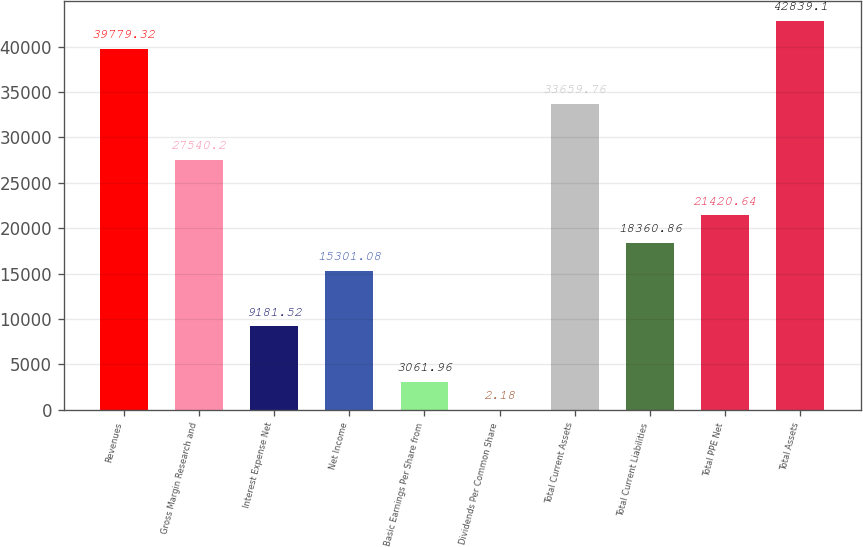Convert chart. <chart><loc_0><loc_0><loc_500><loc_500><bar_chart><fcel>Revenues<fcel>Gross Margin Research and<fcel>Interest Expense Net<fcel>Net Income<fcel>Basic Earnings Per Share from<fcel>Dividends Per Common Share<fcel>Total Current Assets<fcel>Total Current Liabilities<fcel>Total PPE Net<fcel>Total Assets<nl><fcel>39779.3<fcel>27540.2<fcel>9181.52<fcel>15301.1<fcel>3061.96<fcel>2.18<fcel>33659.8<fcel>18360.9<fcel>21420.6<fcel>42839.1<nl></chart> 